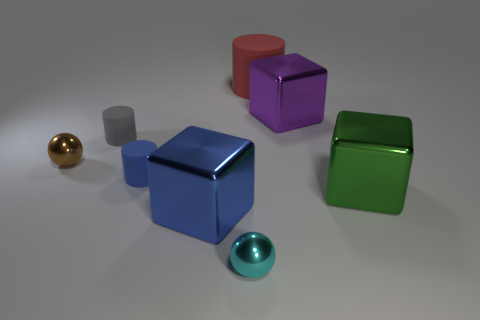There is a sphere that is right of the brown shiny ball; what is it made of?
Your answer should be compact. Metal. Are there any yellow metal cylinders that have the same size as the brown metal object?
Keep it short and to the point. No. What number of blue things are either metallic blocks or rubber blocks?
Give a very brief answer. 1. What number of tiny metal objects have the same color as the large cylinder?
Make the answer very short. 0. Are the brown object and the blue cylinder made of the same material?
Your response must be concise. No. How many large metal objects are on the right side of the big rubber cylinder right of the brown thing?
Ensure brevity in your answer.  2. Do the blue cylinder and the cyan ball have the same size?
Give a very brief answer. Yes. What number of red objects have the same material as the tiny brown sphere?
Offer a terse response. 0. There is a green object that is the same shape as the large blue metal thing; what is its size?
Keep it short and to the point. Large. Do the large metal thing that is behind the green metal thing and the brown object have the same shape?
Provide a succinct answer. No. 